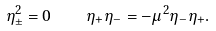<formula> <loc_0><loc_0><loc_500><loc_500>\eta _ { \pm } ^ { 2 } = 0 \quad \eta _ { + } \eta _ { - } = - \mu ^ { 2 } \eta _ { - } \eta _ { + } .</formula> 